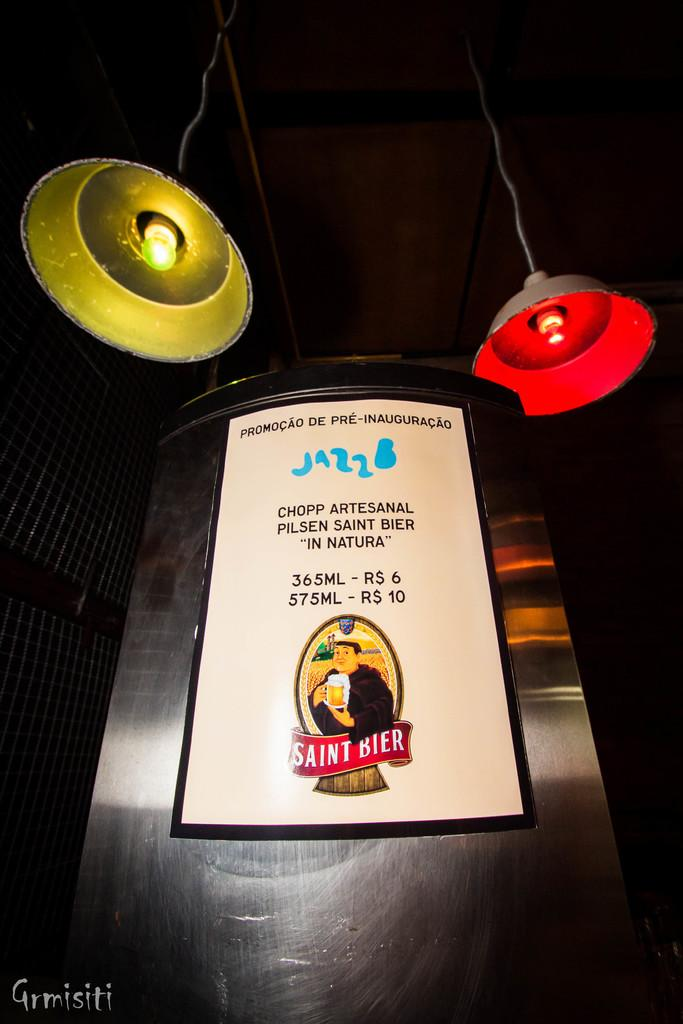Provide a one-sentence caption for the provided image. A poster for Saint Bier hangs near some ceiling lights. 